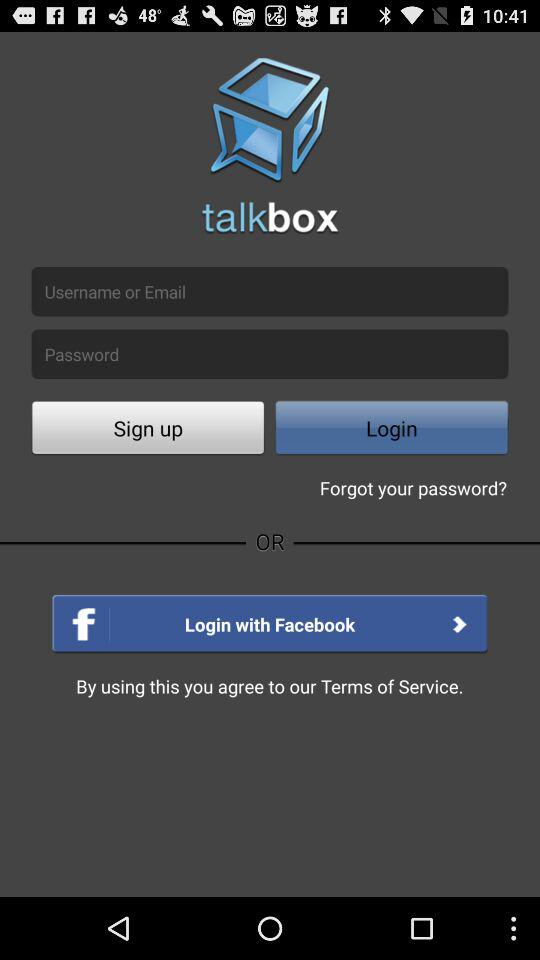Can you describe the layout and design features visible in this application's login screen? The login screen of the 'talkbox' application features a clean and simple design, dominated by dark gray tones and light text for contrast. There's a prominent logo at the top, a typical username and password entry form, and options for signing up or logging in. It also offers the convenience of logging in with Facebook, suggesting an emphasis on social media integration. The buttons are rectangular with rounded edges, fitting modern UI design trends. 